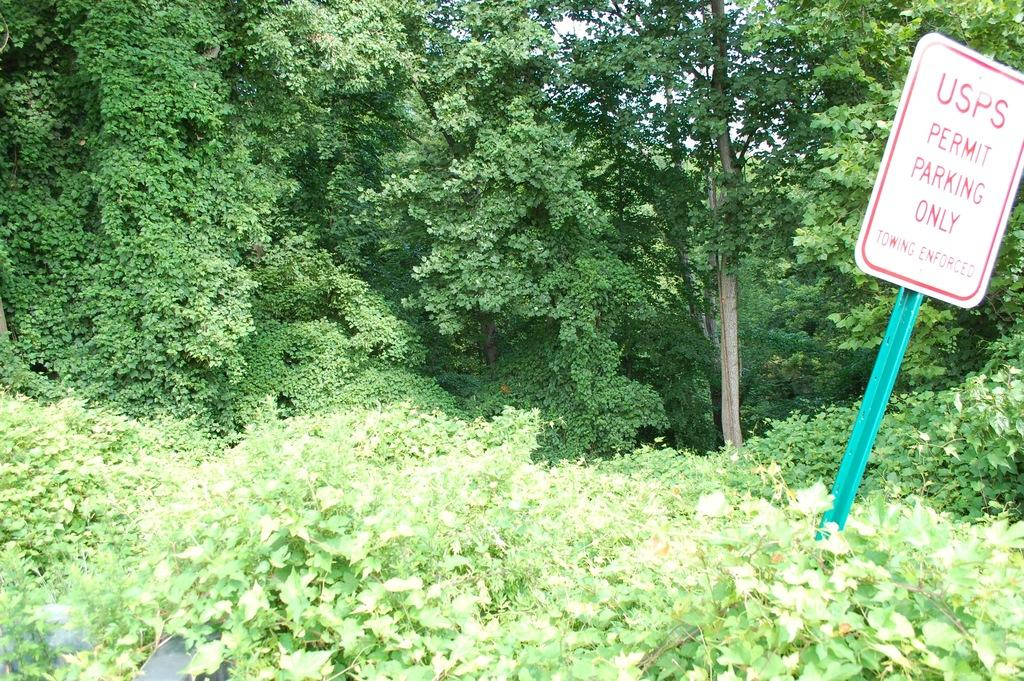What type of vegetation is present in the image? There are trees and plants in the image. Can you describe the board with text on the right side of the image? Yes, there is a board with text on the right side of the image. What might the text on the board be communicating? Without knowing the specific content of the text, it is impossible to determine what it is communicating. What type of bed is visible in the image? There is no bed present in the image; it features trees, plants, and a board with text. 